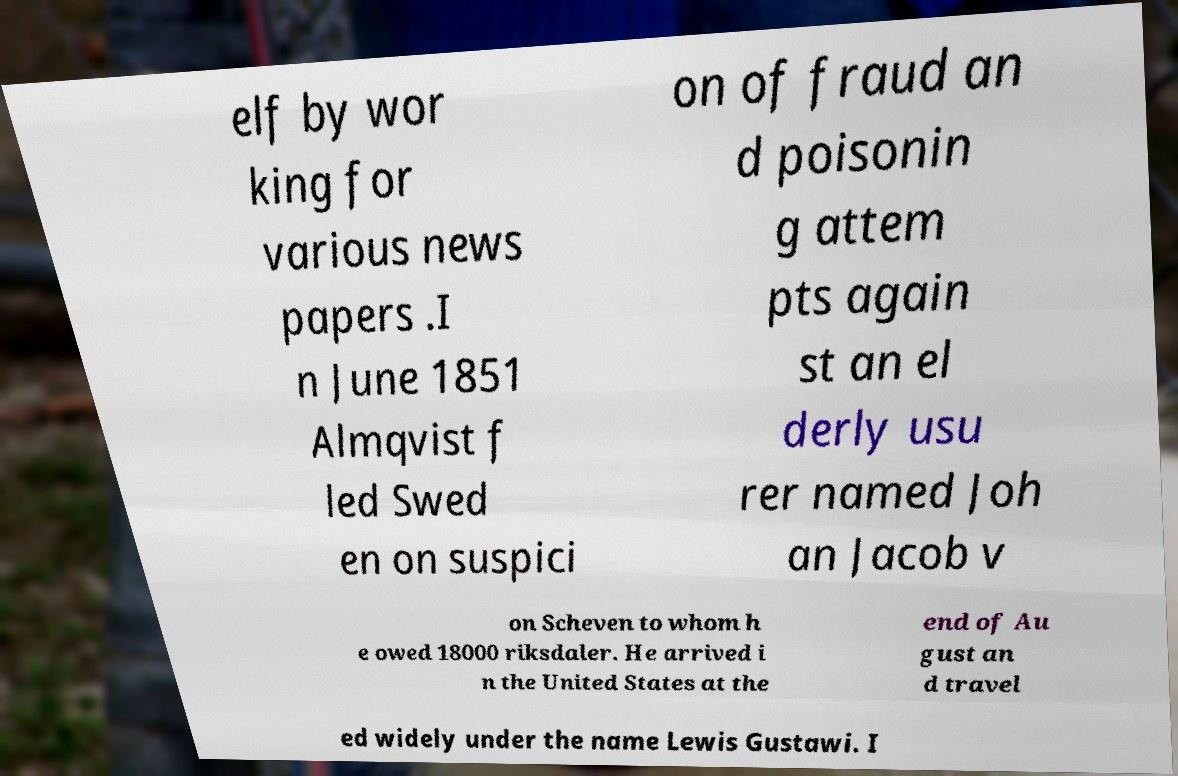For documentation purposes, I need the text within this image transcribed. Could you provide that? elf by wor king for various news papers .I n June 1851 Almqvist f led Swed en on suspici on of fraud an d poisonin g attem pts again st an el derly usu rer named Joh an Jacob v on Scheven to whom h e owed 18000 riksdaler. He arrived i n the United States at the end of Au gust an d travel ed widely under the name Lewis Gustawi. I 